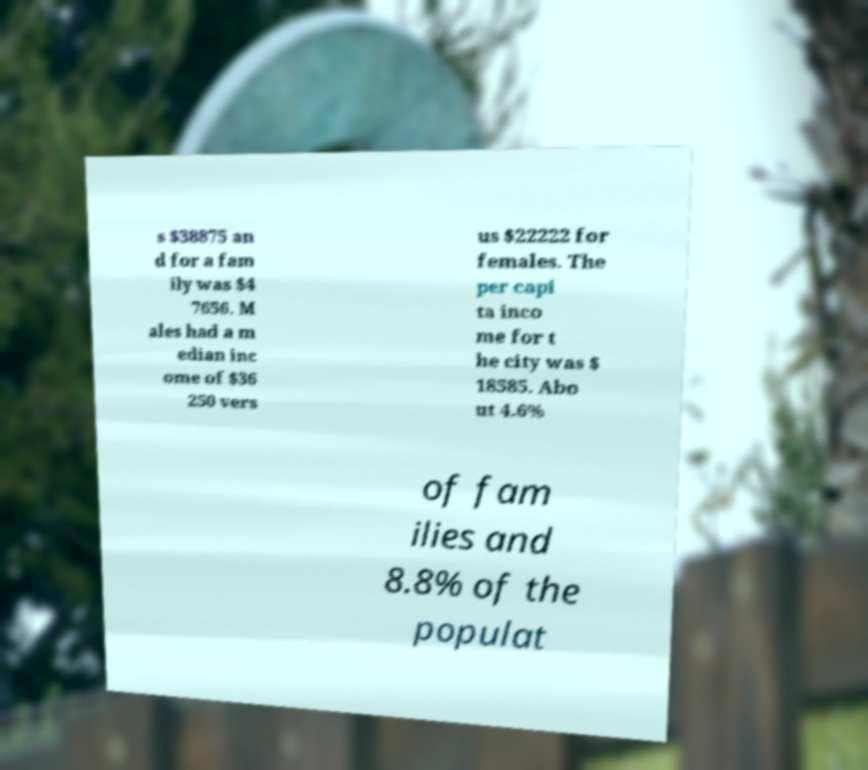Could you extract and type out the text from this image? s $38875 an d for a fam ily was $4 7656. M ales had a m edian inc ome of $36 250 vers us $22222 for females. The per capi ta inco me for t he city was $ 18585. Abo ut 4.6% of fam ilies and 8.8% of the populat 